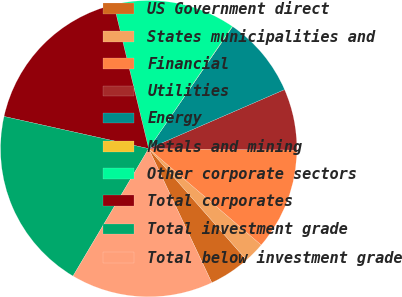Convert chart. <chart><loc_0><loc_0><loc_500><loc_500><pie_chart><fcel>US Government direct<fcel>States municipalities and<fcel>Financial<fcel>Utilities<fcel>Energy<fcel>Metals and mining<fcel>Other corporate sectors<fcel>Total corporates<fcel>Total investment grade<fcel>Total below investment grade<nl><fcel>4.47%<fcel>2.26%<fcel>11.11%<fcel>6.68%<fcel>8.89%<fcel>0.04%<fcel>13.32%<fcel>17.74%<fcel>19.96%<fcel>15.53%<nl></chart> 